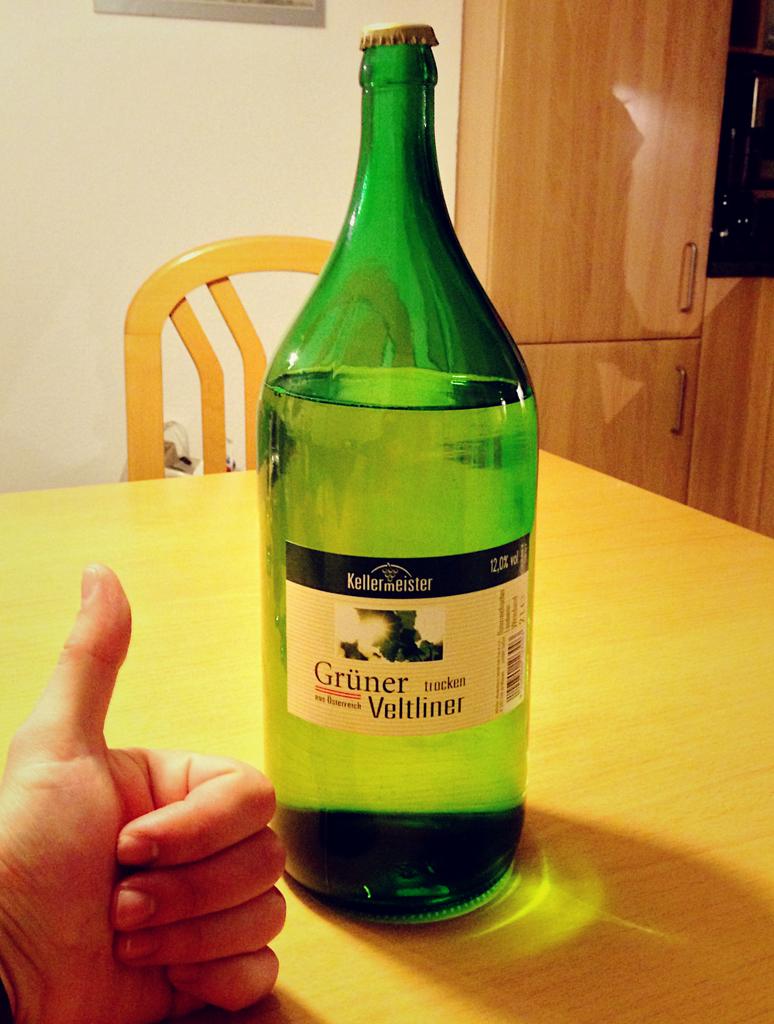Is alcohol on inside the bottle ?
Offer a terse response. Yes. Is gruner veltliner a beer?
Your answer should be compact. Yes. 